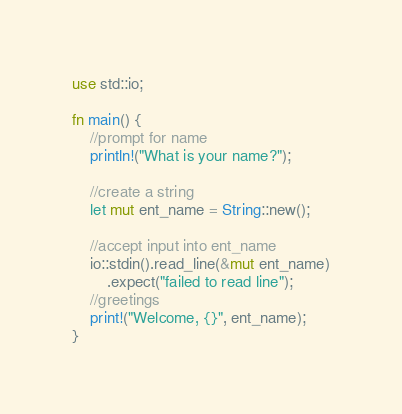Convert code to text. <code><loc_0><loc_0><loc_500><loc_500><_Rust_>use std::io;

fn main() {
    //prompt for name
    println!("What is your name?");
    
    //create a string
    let mut ent_name = String::new();
    
    //accept input into ent_name
    io::stdin().read_line(&mut ent_name)
        .expect("failed to read line");
    //greetings
    print!("Welcome, {}", ent_name);
}
</code> 